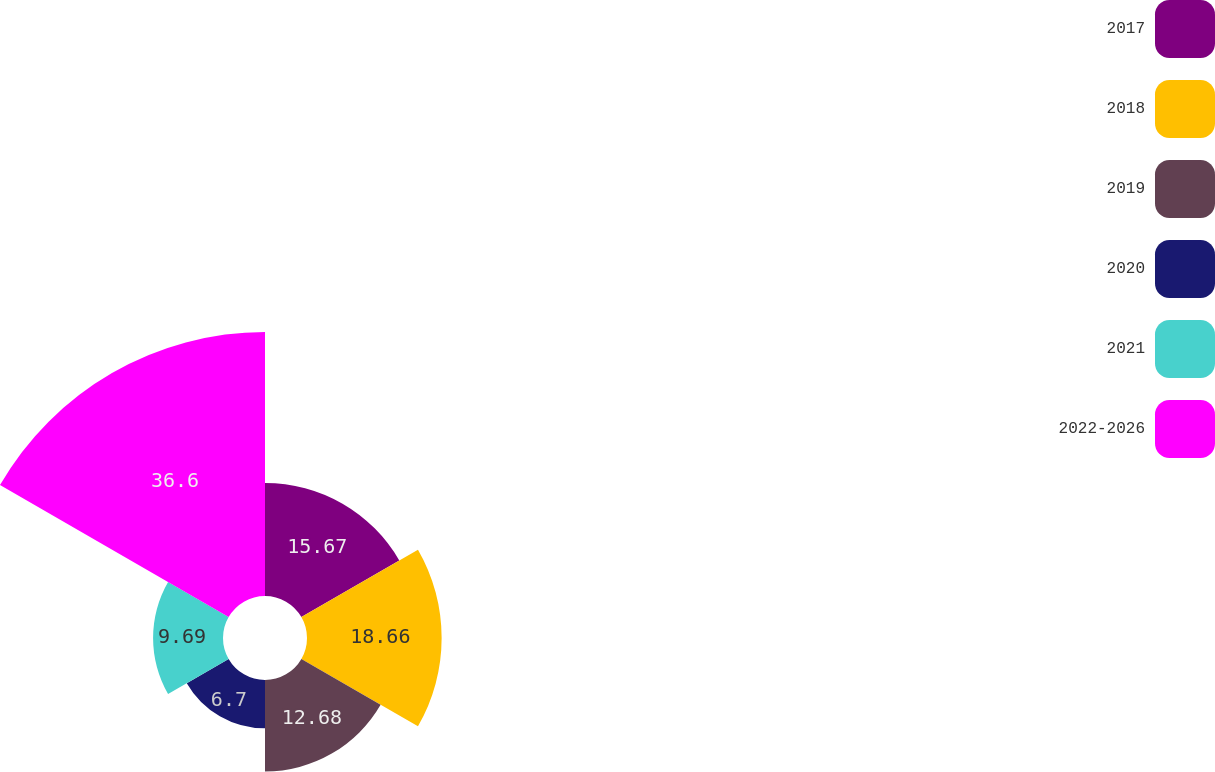Convert chart. <chart><loc_0><loc_0><loc_500><loc_500><pie_chart><fcel>2017<fcel>2018<fcel>2019<fcel>2020<fcel>2021<fcel>2022-2026<nl><fcel>15.67%<fcel>18.66%<fcel>12.68%<fcel>6.7%<fcel>9.69%<fcel>36.59%<nl></chart> 